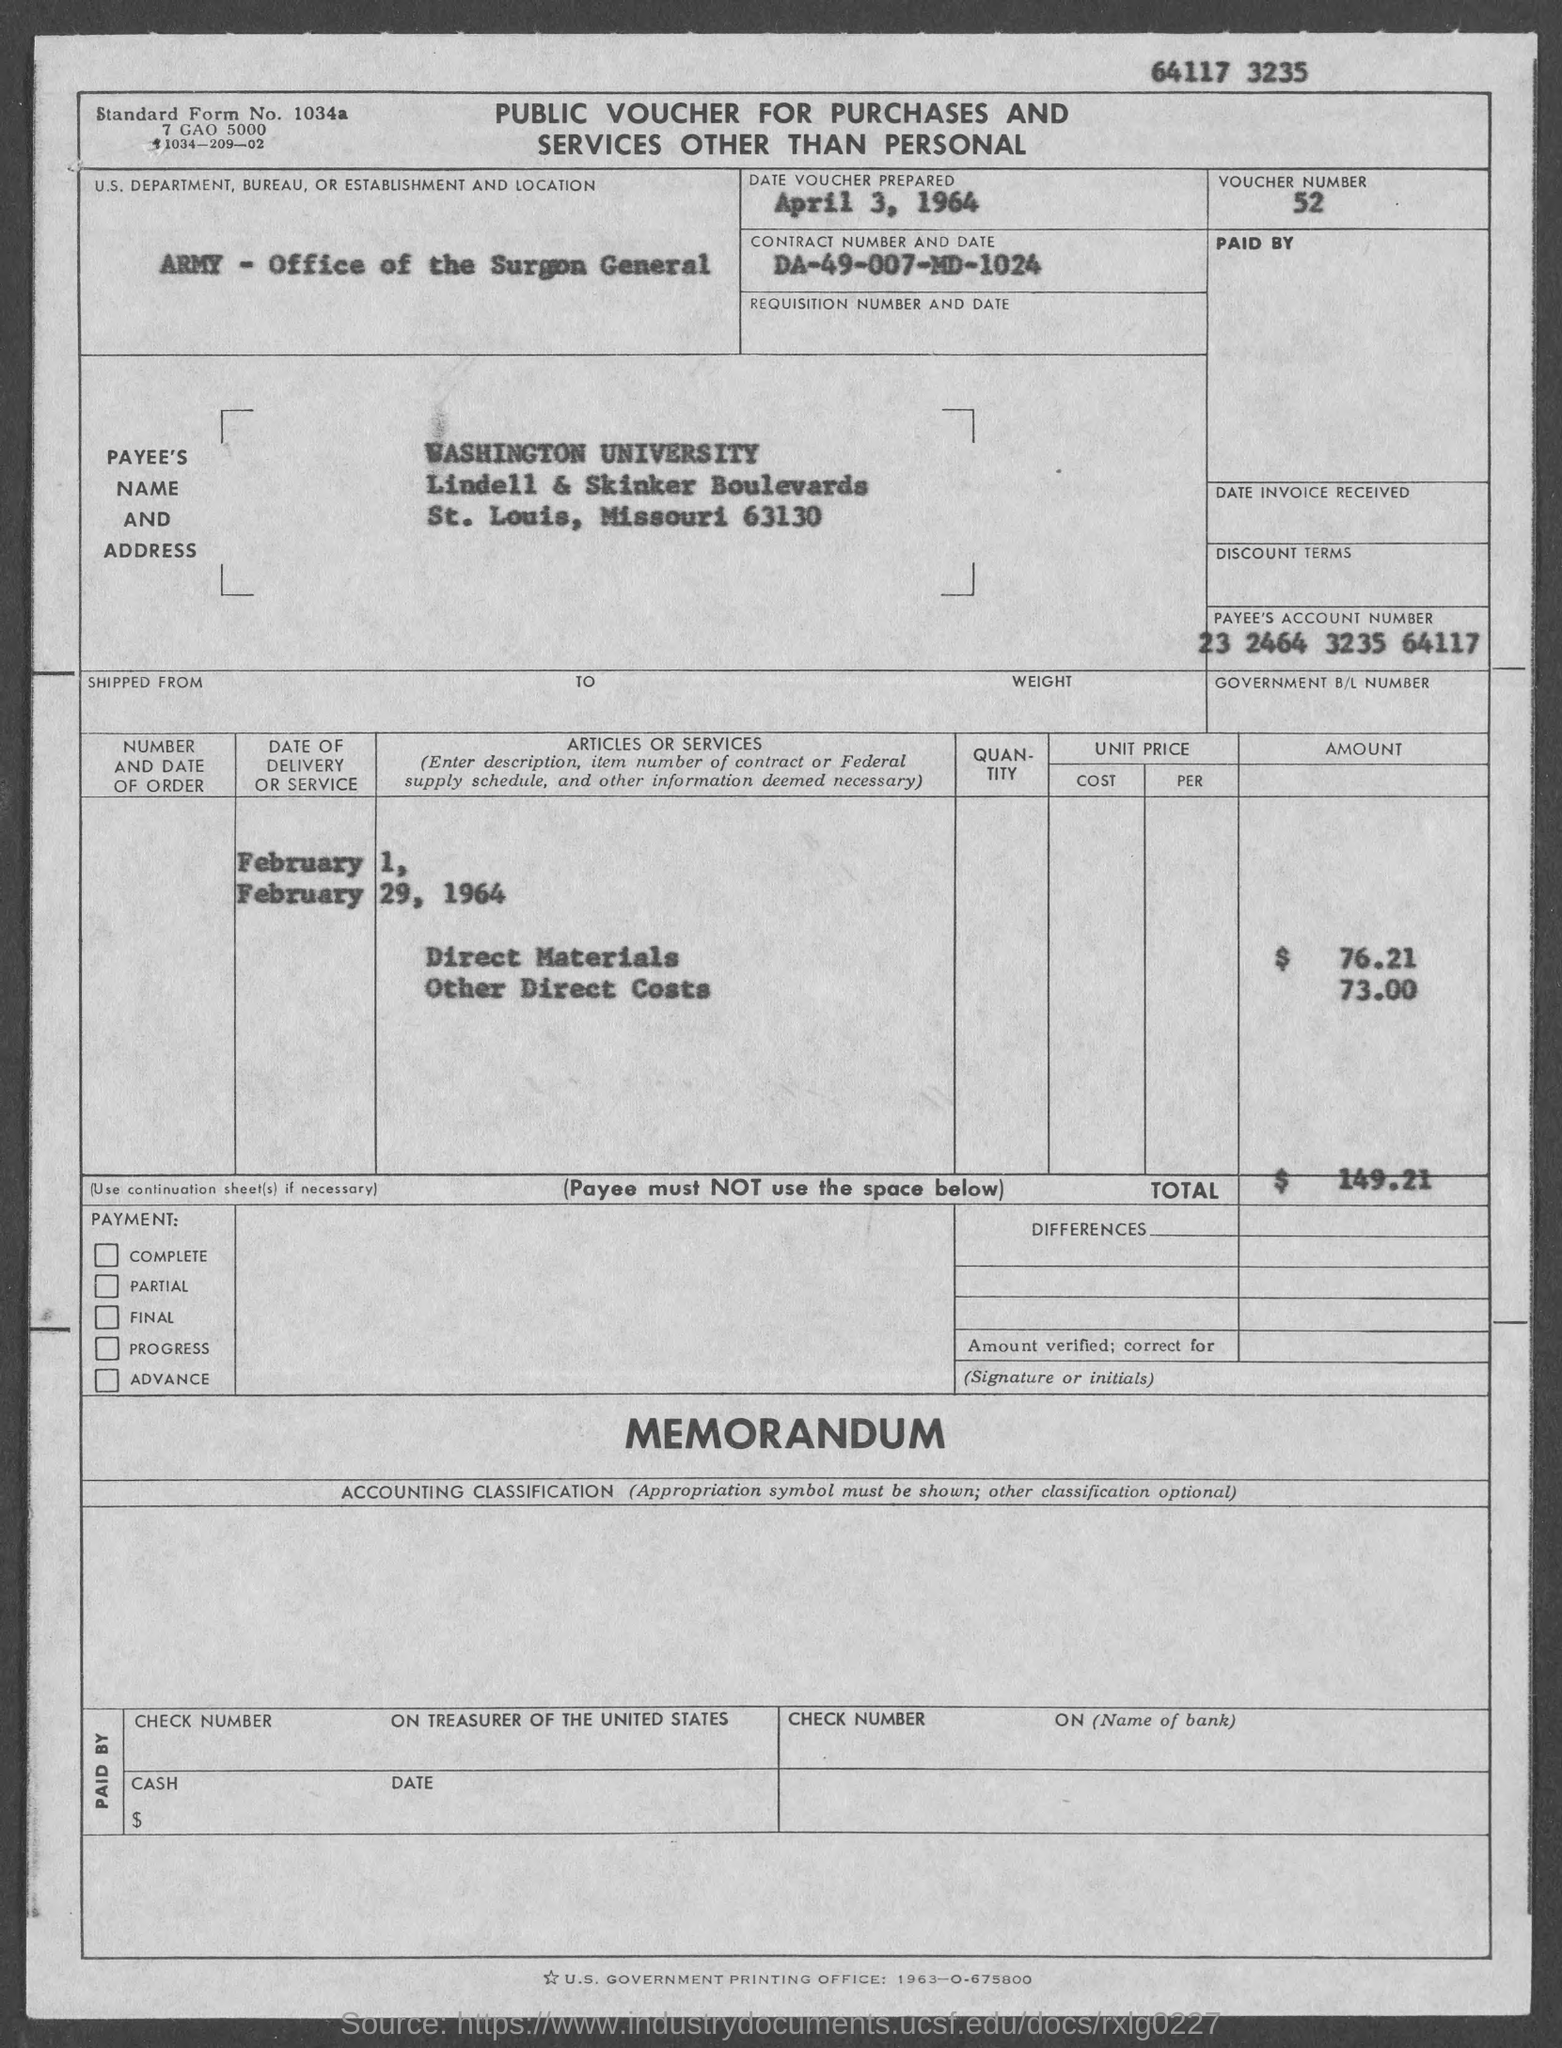What type of voucher is given here?
Ensure brevity in your answer.  PUBLIC VOUCHER FOR PURCHASES AND SERVICES OTHER THAN PERSONAL. What is the voucher number given in the document?
Give a very brief answer. 52. What is the date of voucher prepared?
Offer a terse response. April 3, 1964. What is the U.S. Department, Bureau, or Establishment given in the voucher?
Your response must be concise. ARMY - Office of the Surgeon General. What is the Payee name given in the voucher?
Offer a terse response. WASHINGTON UNIVERSITY. What is the Payee's Account No. given in the voucher?
Ensure brevity in your answer.  23 2464 3235 64117. What is the Standard Form No. given in the voucher?
Your response must be concise. 1034a. What is the Direct materials cost given in the voucher?
Make the answer very short. $ 76.21. What is the total voucher amount mentioned in the document?
Your answer should be very brief. 149.21. 